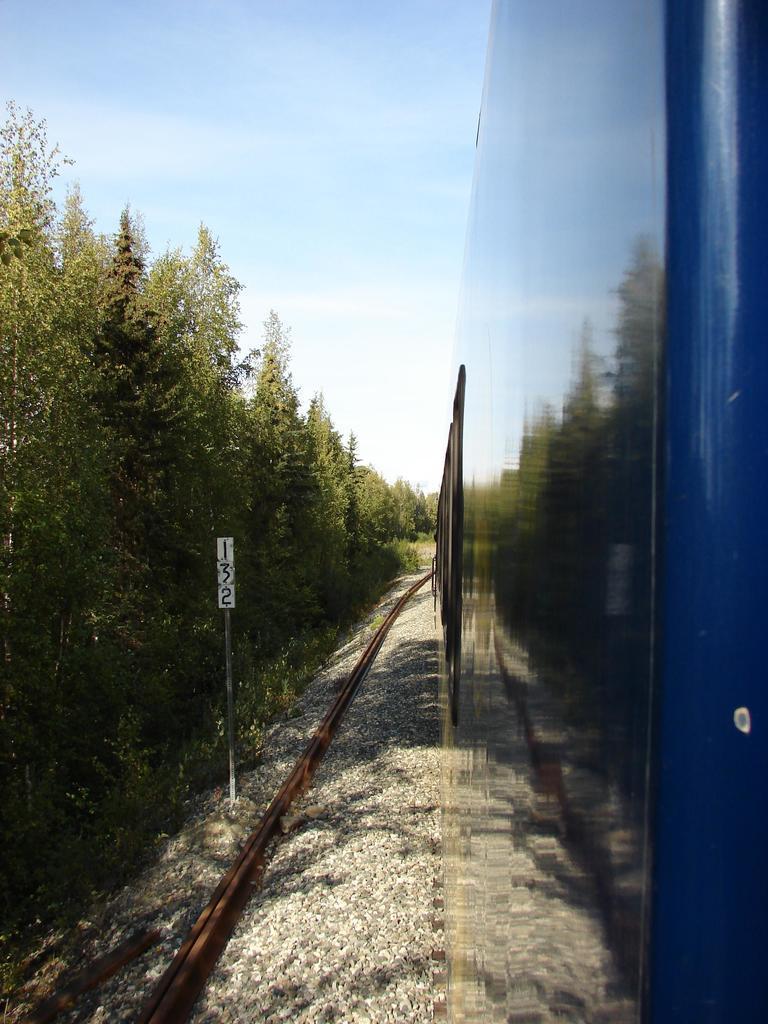Can you describe this image briefly? In the foreground of this image, on right, we see train on the track and on left, there are trees. On top, there is the sky and the cloud. 